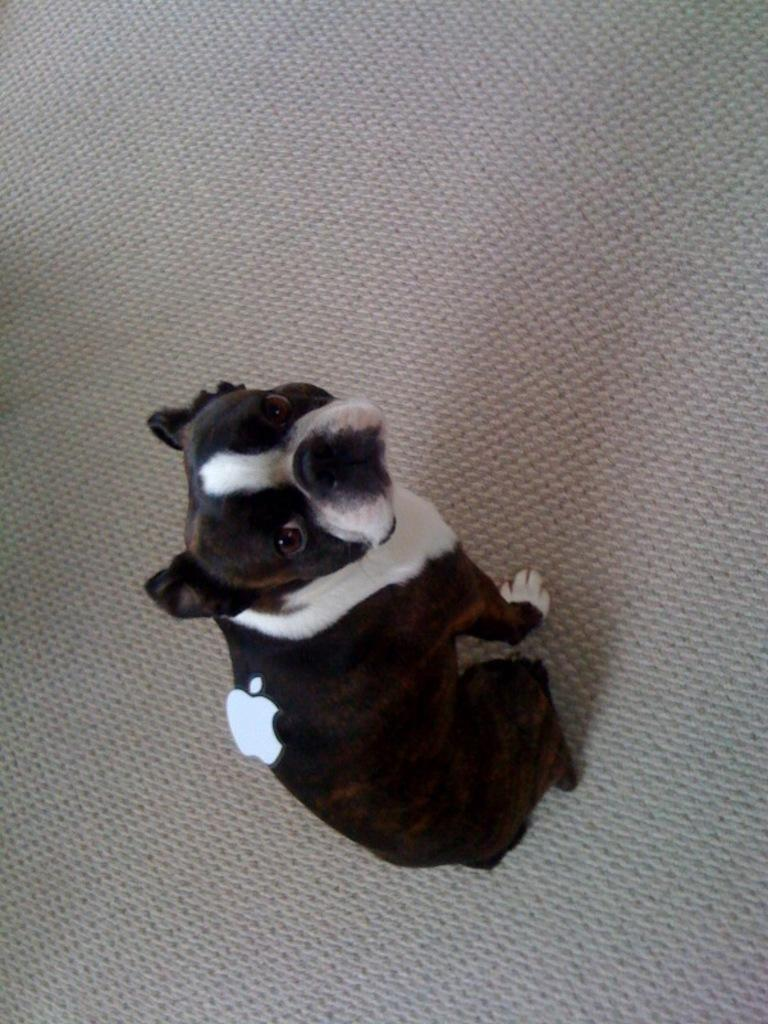What type of animal is in the image? There is a small puppy in the image. Can you describe the color of the puppy? The puppy is black and white in color. What type of power source is visible in the image? There is no power source visible in the image; it only features a small black and white puppy. 